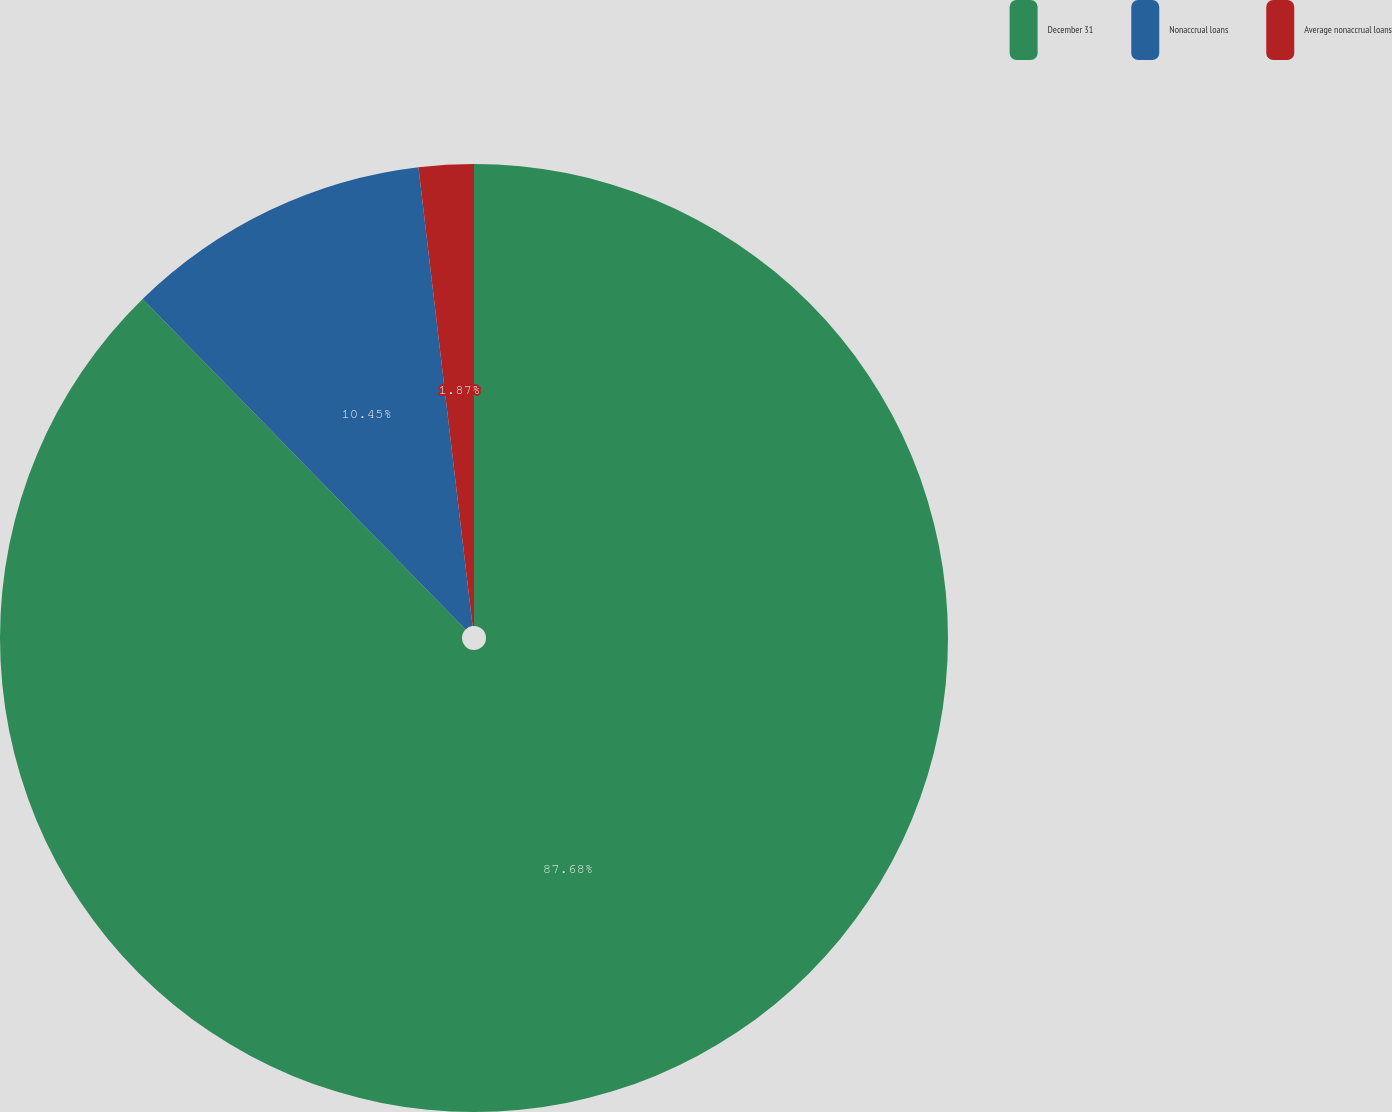Convert chart to OTSL. <chart><loc_0><loc_0><loc_500><loc_500><pie_chart><fcel>December 31<fcel>Nonaccrual loans<fcel>Average nonaccrual loans<nl><fcel>87.67%<fcel>10.45%<fcel>1.87%<nl></chart> 